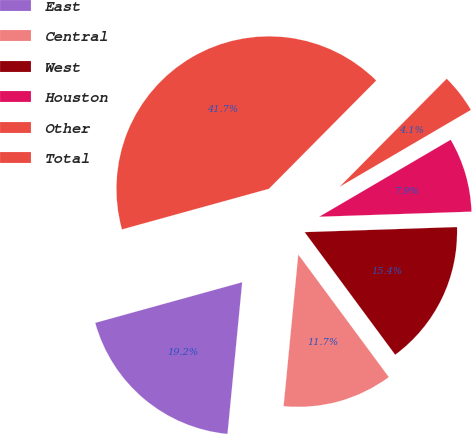Convert chart to OTSL. <chart><loc_0><loc_0><loc_500><loc_500><pie_chart><fcel>East<fcel>Central<fcel>West<fcel>Houston<fcel>Other<fcel>Total<nl><fcel>19.17%<fcel>11.66%<fcel>15.41%<fcel>7.9%<fcel>4.14%<fcel>41.72%<nl></chart> 